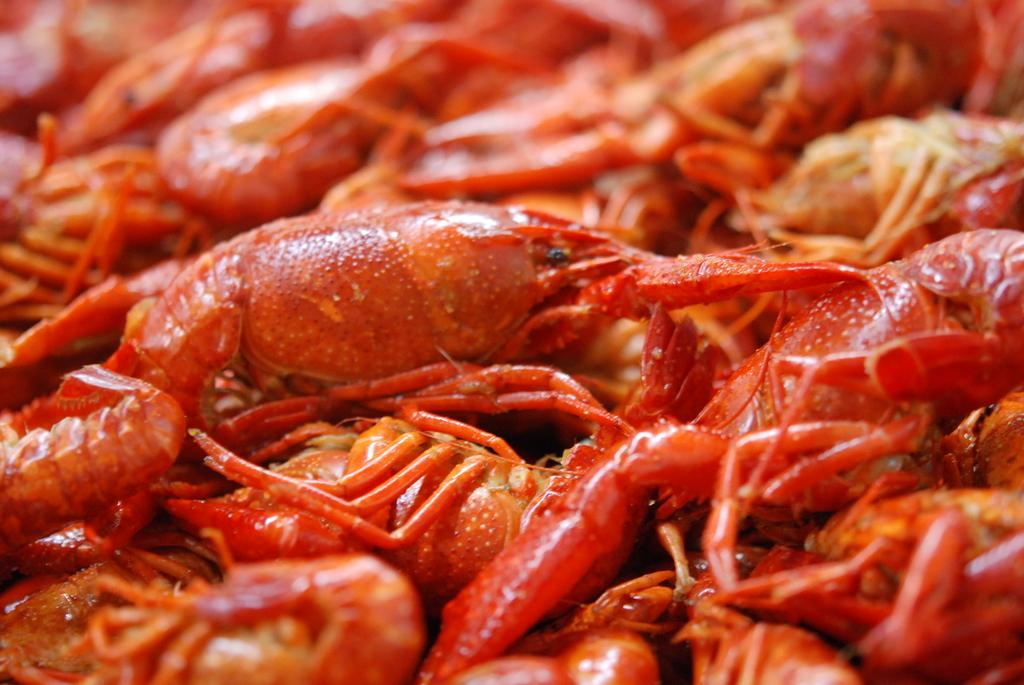What type of animals are present in the image? There are crabs in the image. Where is the bed located in the image? There is no bed present in the image; it only features crabs. What type of performance is happening on the stage in the image? There is no stage or performance present in the image; it only features crabs. 